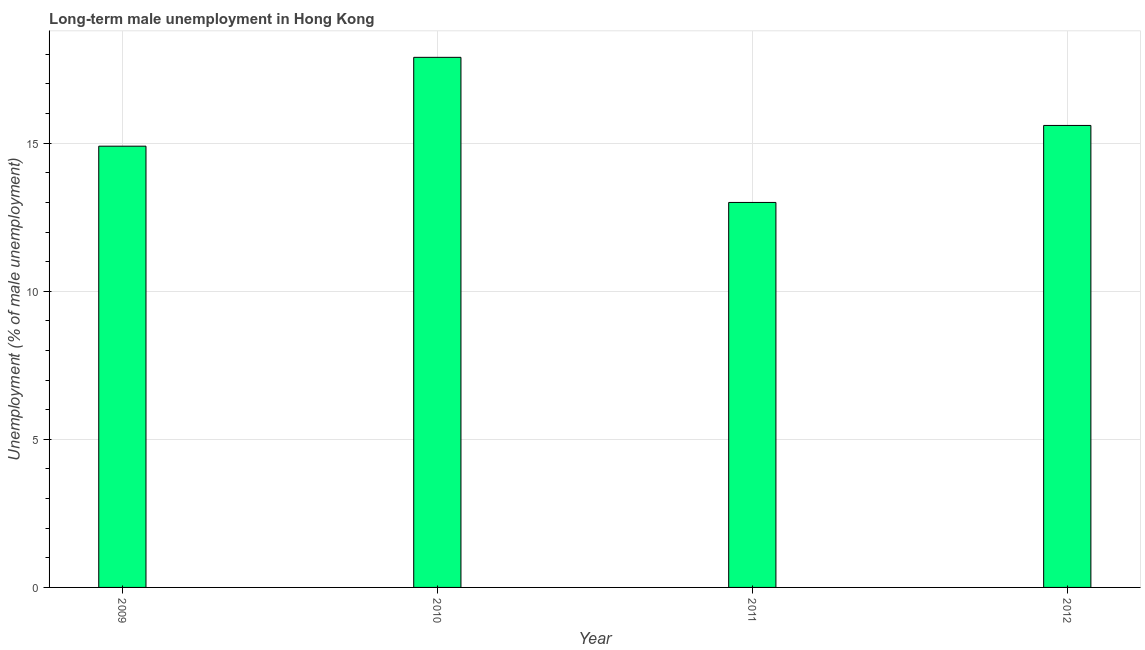Does the graph contain grids?
Provide a short and direct response. Yes. What is the title of the graph?
Provide a short and direct response. Long-term male unemployment in Hong Kong. What is the label or title of the Y-axis?
Ensure brevity in your answer.  Unemployment (% of male unemployment). What is the long-term male unemployment in 2012?
Your answer should be compact. 15.6. Across all years, what is the maximum long-term male unemployment?
Your response must be concise. 17.9. Across all years, what is the minimum long-term male unemployment?
Your response must be concise. 13. In which year was the long-term male unemployment minimum?
Offer a very short reply. 2011. What is the sum of the long-term male unemployment?
Your answer should be very brief. 61.4. What is the difference between the long-term male unemployment in 2010 and 2011?
Keep it short and to the point. 4.9. What is the average long-term male unemployment per year?
Your response must be concise. 15.35. What is the median long-term male unemployment?
Ensure brevity in your answer.  15.25. What is the ratio of the long-term male unemployment in 2010 to that in 2012?
Provide a succinct answer. 1.15. Is the difference between the long-term male unemployment in 2009 and 2010 greater than the difference between any two years?
Make the answer very short. No. Is the sum of the long-term male unemployment in 2010 and 2012 greater than the maximum long-term male unemployment across all years?
Your answer should be compact. Yes. Are all the bars in the graph horizontal?
Offer a very short reply. No. How many years are there in the graph?
Give a very brief answer. 4. Are the values on the major ticks of Y-axis written in scientific E-notation?
Make the answer very short. No. What is the Unemployment (% of male unemployment) in 2009?
Offer a terse response. 14.9. What is the Unemployment (% of male unemployment) of 2010?
Offer a very short reply. 17.9. What is the Unemployment (% of male unemployment) of 2011?
Give a very brief answer. 13. What is the Unemployment (% of male unemployment) of 2012?
Provide a succinct answer. 15.6. What is the difference between the Unemployment (% of male unemployment) in 2009 and 2010?
Ensure brevity in your answer.  -3. What is the difference between the Unemployment (% of male unemployment) in 2009 and 2011?
Give a very brief answer. 1.9. What is the difference between the Unemployment (% of male unemployment) in 2010 and 2012?
Offer a terse response. 2.3. What is the ratio of the Unemployment (% of male unemployment) in 2009 to that in 2010?
Ensure brevity in your answer.  0.83. What is the ratio of the Unemployment (% of male unemployment) in 2009 to that in 2011?
Keep it short and to the point. 1.15. What is the ratio of the Unemployment (% of male unemployment) in 2009 to that in 2012?
Provide a succinct answer. 0.95. What is the ratio of the Unemployment (% of male unemployment) in 2010 to that in 2011?
Your answer should be very brief. 1.38. What is the ratio of the Unemployment (% of male unemployment) in 2010 to that in 2012?
Offer a terse response. 1.15. What is the ratio of the Unemployment (% of male unemployment) in 2011 to that in 2012?
Your answer should be very brief. 0.83. 